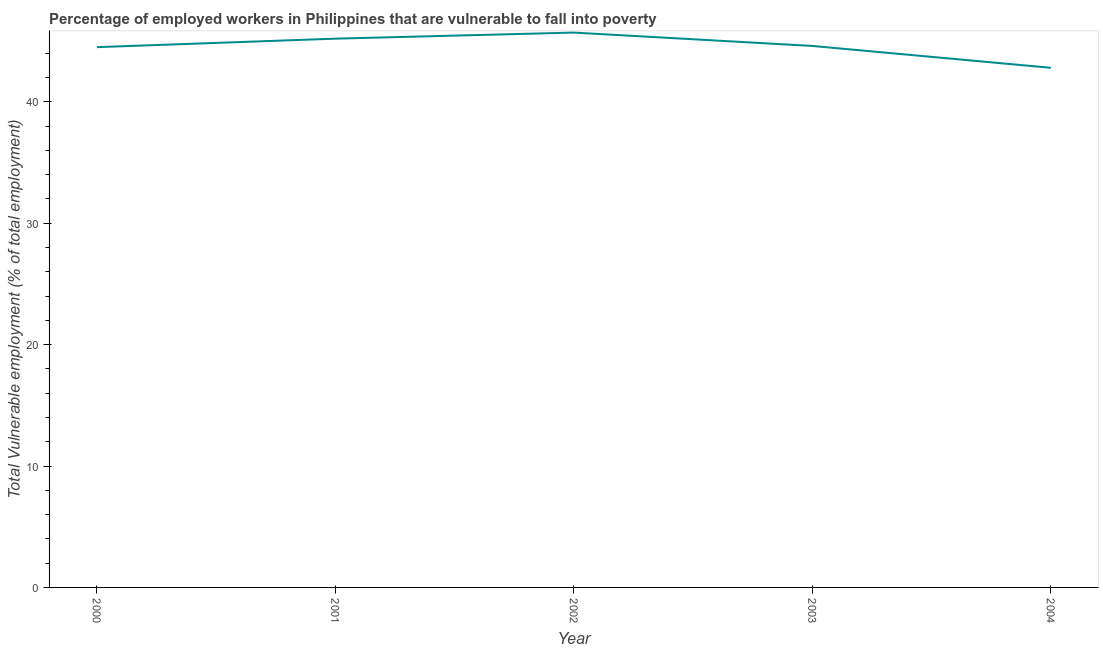What is the total vulnerable employment in 2000?
Give a very brief answer. 44.5. Across all years, what is the maximum total vulnerable employment?
Your answer should be very brief. 45.7. Across all years, what is the minimum total vulnerable employment?
Make the answer very short. 42.8. In which year was the total vulnerable employment maximum?
Provide a succinct answer. 2002. In which year was the total vulnerable employment minimum?
Your answer should be very brief. 2004. What is the sum of the total vulnerable employment?
Your answer should be very brief. 222.8. What is the difference between the total vulnerable employment in 2000 and 2001?
Give a very brief answer. -0.7. What is the average total vulnerable employment per year?
Offer a very short reply. 44.56. What is the median total vulnerable employment?
Keep it short and to the point. 44.6. What is the ratio of the total vulnerable employment in 2001 to that in 2004?
Provide a short and direct response. 1.06. Is the sum of the total vulnerable employment in 2000 and 2002 greater than the maximum total vulnerable employment across all years?
Offer a very short reply. Yes. What is the difference between the highest and the lowest total vulnerable employment?
Offer a very short reply. 2.9. In how many years, is the total vulnerable employment greater than the average total vulnerable employment taken over all years?
Ensure brevity in your answer.  3. How many lines are there?
Offer a very short reply. 1. What is the difference between two consecutive major ticks on the Y-axis?
Offer a terse response. 10. Are the values on the major ticks of Y-axis written in scientific E-notation?
Give a very brief answer. No. Does the graph contain any zero values?
Keep it short and to the point. No. What is the title of the graph?
Your answer should be compact. Percentage of employed workers in Philippines that are vulnerable to fall into poverty. What is the label or title of the Y-axis?
Provide a succinct answer. Total Vulnerable employment (% of total employment). What is the Total Vulnerable employment (% of total employment) in 2000?
Ensure brevity in your answer.  44.5. What is the Total Vulnerable employment (% of total employment) of 2001?
Keep it short and to the point. 45.2. What is the Total Vulnerable employment (% of total employment) of 2002?
Offer a terse response. 45.7. What is the Total Vulnerable employment (% of total employment) in 2003?
Offer a very short reply. 44.6. What is the Total Vulnerable employment (% of total employment) of 2004?
Offer a terse response. 42.8. What is the difference between the Total Vulnerable employment (% of total employment) in 2000 and 2001?
Provide a succinct answer. -0.7. What is the difference between the Total Vulnerable employment (% of total employment) in 2000 and 2002?
Keep it short and to the point. -1.2. What is the difference between the Total Vulnerable employment (% of total employment) in 2000 and 2003?
Keep it short and to the point. -0.1. What is the difference between the Total Vulnerable employment (% of total employment) in 2000 and 2004?
Ensure brevity in your answer.  1.7. What is the difference between the Total Vulnerable employment (% of total employment) in 2001 and 2004?
Your answer should be very brief. 2.4. What is the difference between the Total Vulnerable employment (% of total employment) in 2002 and 2003?
Your answer should be compact. 1.1. What is the ratio of the Total Vulnerable employment (% of total employment) in 2000 to that in 2001?
Your answer should be compact. 0.98. What is the ratio of the Total Vulnerable employment (% of total employment) in 2000 to that in 2004?
Provide a short and direct response. 1.04. What is the ratio of the Total Vulnerable employment (% of total employment) in 2001 to that in 2003?
Your response must be concise. 1.01. What is the ratio of the Total Vulnerable employment (% of total employment) in 2001 to that in 2004?
Your response must be concise. 1.06. What is the ratio of the Total Vulnerable employment (% of total employment) in 2002 to that in 2003?
Give a very brief answer. 1.02. What is the ratio of the Total Vulnerable employment (% of total employment) in 2002 to that in 2004?
Provide a succinct answer. 1.07. What is the ratio of the Total Vulnerable employment (% of total employment) in 2003 to that in 2004?
Your response must be concise. 1.04. 